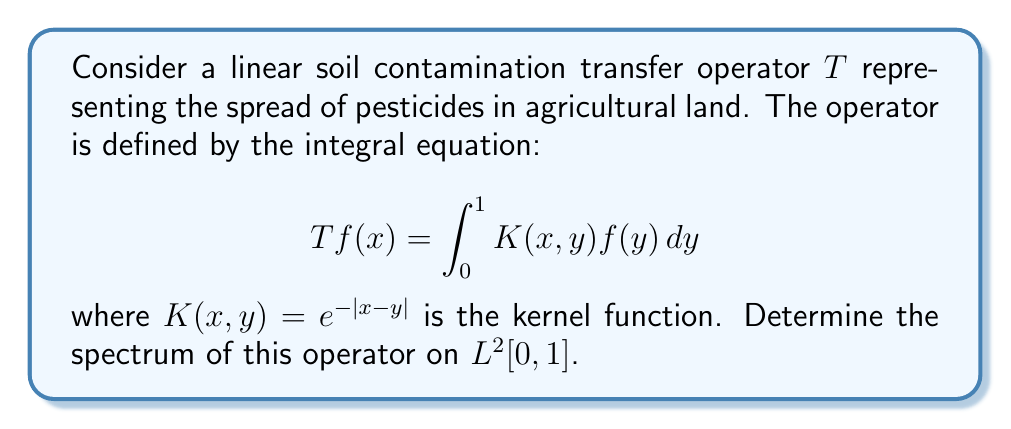Teach me how to tackle this problem. To determine the spectrum of the operator $T$, we follow these steps:

1) First, note that $T$ is a compact operator on $L^2[0,1]$ because it has a continuous kernel.

2) For compact operators, the spectrum consists of 0 and the eigenvalues. So, we need to find the eigenvalues.

3) The eigenvalue equation is:

   $$T f(x) = \lambda f(x)$$

   which expands to:

   $$\int_0^1 e^{-|x-y|} f(y) dy = \lambda f(x)$$

4) Differentiating both sides twice with respect to $x$:

   $$\frac{d^2}{dx^2} \int_0^1 e^{-|x-y|} f(y) dy = \lambda \frac{d^2f}{dx^2}(x)$$

   $$f(x) - \int_0^1 e^{-|x-y|} f(y) dy = \lambda \frac{d^2f}{dx^2}(x)$$

5) Substituting the original equation:

   $$f(x) - \lambda f(x) = \lambda \frac{d^2f}{dx^2}(x)$$

   $$\frac{d^2f}{dx^2}(x) = \frac{1-\lambda}{\lambda} f(x)$$

6) This is a second-order differential equation with general solution:

   $$f(x) = A \cos(\omega x) + B \sin(\omega x)$$

   where $\omega^2 = \frac{1-\lambda}{\lambda}$

7) The eigenvalues are determined by the boundary conditions. Substituting the general solution back into the original integral equation and solving leads to the characteristic equation:

   $$\frac{1}{\lambda} = 1 + \omega^2$$

8) Solving this equation gives:

   $$\lambda_n = \frac{1}{1+n^2\pi^2}$$

   for $n = 0, 1, 2, ...$

Therefore, the spectrum of $T$ consists of 0 and the sequence of eigenvalues $\{\frac{1}{1+n^2\pi^2}\}_{n=0}^\infty$.
Answer: $\{0\} \cup \{\frac{1}{1+n^2\pi^2} : n \in \mathbb{N}_0\}$ 